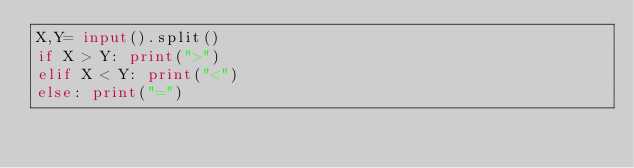<code> <loc_0><loc_0><loc_500><loc_500><_Python_>X,Y= input().split()
if X > Y: print(">")
elif X < Y: print("<")
else: print("=")</code> 